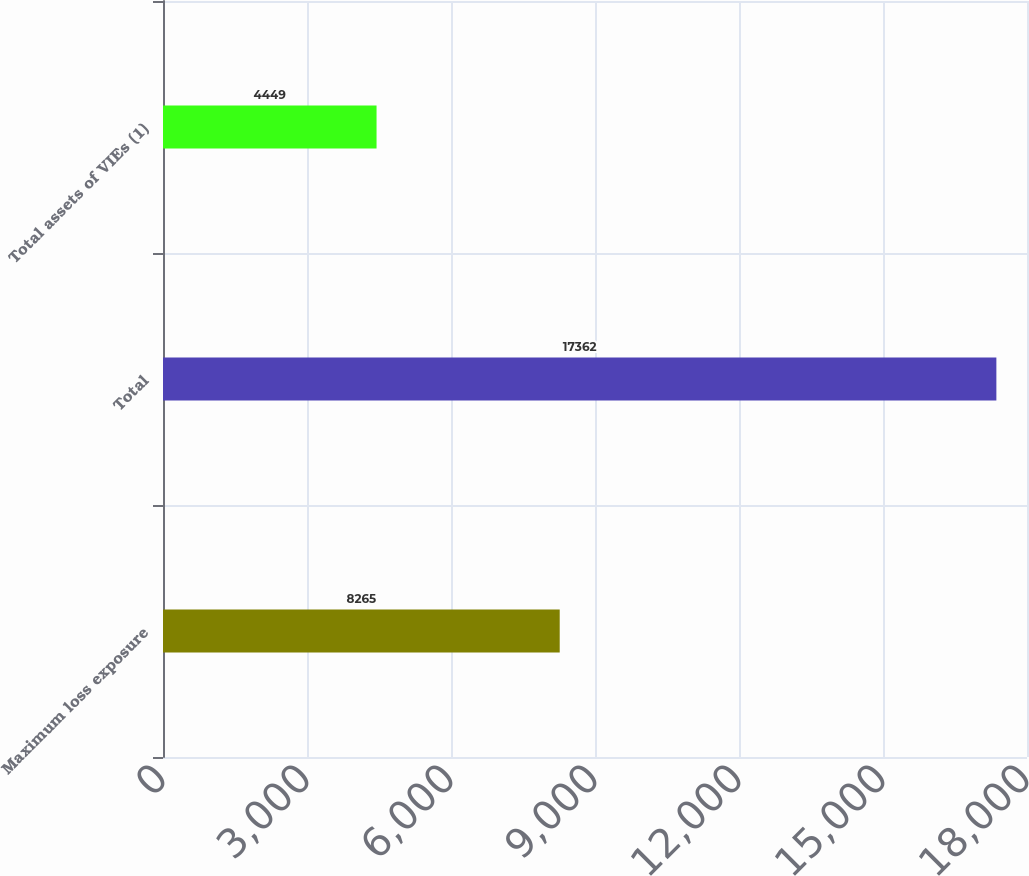Convert chart. <chart><loc_0><loc_0><loc_500><loc_500><bar_chart><fcel>Maximum loss exposure<fcel>Total<fcel>Total assets of VIEs (1)<nl><fcel>8265<fcel>17362<fcel>4449<nl></chart> 